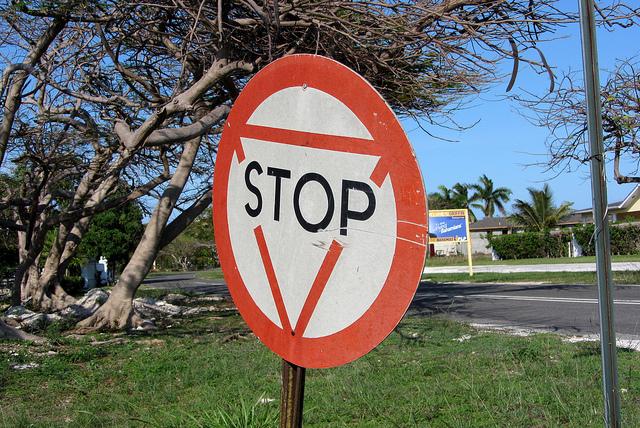What is the sign saying?
Keep it brief. Stop. What color is the sign?
Quick response, please. Red and white. Are there any palm trees in the picture?
Short answer required. Yes. 